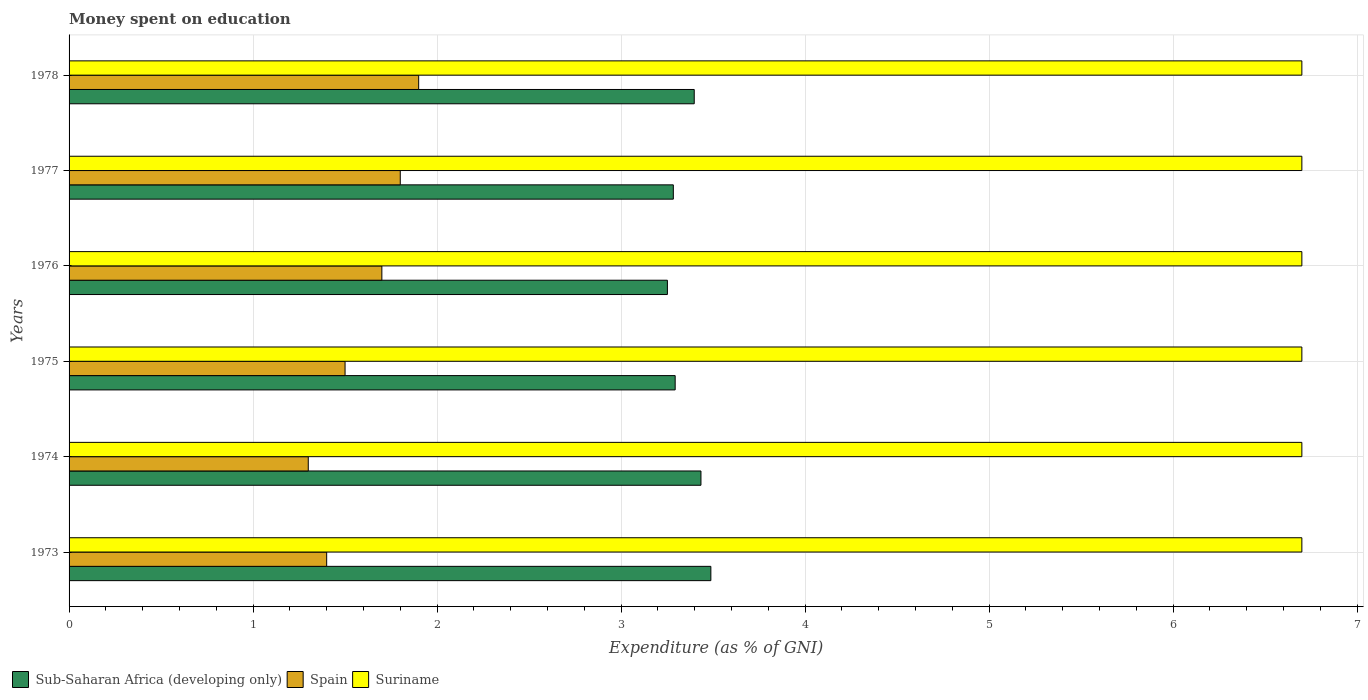How many groups of bars are there?
Give a very brief answer. 6. Are the number of bars on each tick of the Y-axis equal?
Keep it short and to the point. Yes. How many bars are there on the 1st tick from the top?
Make the answer very short. 3. How many bars are there on the 2nd tick from the bottom?
Offer a very short reply. 3. What is the label of the 4th group of bars from the top?
Provide a succinct answer. 1975. What is the amount of money spent on education in Spain in 1978?
Offer a terse response. 1.9. Across all years, what is the maximum amount of money spent on education in Sub-Saharan Africa (developing only)?
Your response must be concise. 3.49. Across all years, what is the minimum amount of money spent on education in Sub-Saharan Africa (developing only)?
Offer a terse response. 3.25. In which year was the amount of money spent on education in Sub-Saharan Africa (developing only) maximum?
Give a very brief answer. 1973. In which year was the amount of money spent on education in Sub-Saharan Africa (developing only) minimum?
Your answer should be very brief. 1976. What is the total amount of money spent on education in Spain in the graph?
Your answer should be compact. 9.6. What is the difference between the amount of money spent on education in Sub-Saharan Africa (developing only) in 1974 and that in 1977?
Keep it short and to the point. 0.15. What is the difference between the amount of money spent on education in Suriname in 1977 and the amount of money spent on education in Sub-Saharan Africa (developing only) in 1976?
Your answer should be compact. 3.45. What is the average amount of money spent on education in Sub-Saharan Africa (developing only) per year?
Your answer should be very brief. 3.36. In the year 1977, what is the difference between the amount of money spent on education in Sub-Saharan Africa (developing only) and amount of money spent on education in Suriname?
Offer a very short reply. -3.42. What is the ratio of the amount of money spent on education in Suriname in 1976 to that in 1978?
Provide a succinct answer. 1. What is the difference between the highest and the second highest amount of money spent on education in Sub-Saharan Africa (developing only)?
Your answer should be very brief. 0.05. What is the difference between the highest and the lowest amount of money spent on education in Sub-Saharan Africa (developing only)?
Provide a short and direct response. 0.24. Is the sum of the amount of money spent on education in Spain in 1974 and 1977 greater than the maximum amount of money spent on education in Sub-Saharan Africa (developing only) across all years?
Make the answer very short. No. What does the 3rd bar from the top in 1973 represents?
Provide a succinct answer. Sub-Saharan Africa (developing only). What does the 2nd bar from the bottom in 1975 represents?
Your response must be concise. Spain. Is it the case that in every year, the sum of the amount of money spent on education in Sub-Saharan Africa (developing only) and amount of money spent on education in Spain is greater than the amount of money spent on education in Suriname?
Make the answer very short. No. Are all the bars in the graph horizontal?
Offer a terse response. Yes. How many years are there in the graph?
Provide a succinct answer. 6. What is the difference between two consecutive major ticks on the X-axis?
Provide a short and direct response. 1. Where does the legend appear in the graph?
Your answer should be compact. Bottom left. How many legend labels are there?
Your response must be concise. 3. What is the title of the graph?
Provide a short and direct response. Money spent on education. What is the label or title of the X-axis?
Your response must be concise. Expenditure (as % of GNI). What is the label or title of the Y-axis?
Your response must be concise. Years. What is the Expenditure (as % of GNI) of Sub-Saharan Africa (developing only) in 1973?
Give a very brief answer. 3.49. What is the Expenditure (as % of GNI) of Suriname in 1973?
Provide a short and direct response. 6.7. What is the Expenditure (as % of GNI) of Sub-Saharan Africa (developing only) in 1974?
Ensure brevity in your answer.  3.43. What is the Expenditure (as % of GNI) in Spain in 1974?
Your answer should be very brief. 1.3. What is the Expenditure (as % of GNI) of Sub-Saharan Africa (developing only) in 1975?
Provide a short and direct response. 3.29. What is the Expenditure (as % of GNI) in Spain in 1975?
Provide a short and direct response. 1.5. What is the Expenditure (as % of GNI) in Suriname in 1975?
Offer a very short reply. 6.7. What is the Expenditure (as % of GNI) of Sub-Saharan Africa (developing only) in 1976?
Your answer should be very brief. 3.25. What is the Expenditure (as % of GNI) of Spain in 1976?
Keep it short and to the point. 1.7. What is the Expenditure (as % of GNI) of Sub-Saharan Africa (developing only) in 1977?
Ensure brevity in your answer.  3.28. What is the Expenditure (as % of GNI) in Suriname in 1977?
Make the answer very short. 6.7. What is the Expenditure (as % of GNI) of Sub-Saharan Africa (developing only) in 1978?
Give a very brief answer. 3.4. Across all years, what is the maximum Expenditure (as % of GNI) in Sub-Saharan Africa (developing only)?
Your answer should be compact. 3.49. Across all years, what is the maximum Expenditure (as % of GNI) in Suriname?
Make the answer very short. 6.7. Across all years, what is the minimum Expenditure (as % of GNI) in Sub-Saharan Africa (developing only)?
Your answer should be very brief. 3.25. Across all years, what is the minimum Expenditure (as % of GNI) of Spain?
Offer a terse response. 1.3. Across all years, what is the minimum Expenditure (as % of GNI) in Suriname?
Your answer should be compact. 6.7. What is the total Expenditure (as % of GNI) in Sub-Saharan Africa (developing only) in the graph?
Make the answer very short. 20.15. What is the total Expenditure (as % of GNI) of Spain in the graph?
Provide a short and direct response. 9.6. What is the total Expenditure (as % of GNI) of Suriname in the graph?
Your answer should be very brief. 40.2. What is the difference between the Expenditure (as % of GNI) in Sub-Saharan Africa (developing only) in 1973 and that in 1974?
Your answer should be compact. 0.05. What is the difference between the Expenditure (as % of GNI) in Spain in 1973 and that in 1974?
Give a very brief answer. 0.1. What is the difference between the Expenditure (as % of GNI) of Suriname in 1973 and that in 1974?
Keep it short and to the point. 0. What is the difference between the Expenditure (as % of GNI) in Sub-Saharan Africa (developing only) in 1973 and that in 1975?
Your answer should be very brief. 0.19. What is the difference between the Expenditure (as % of GNI) in Spain in 1973 and that in 1975?
Ensure brevity in your answer.  -0.1. What is the difference between the Expenditure (as % of GNI) in Suriname in 1973 and that in 1975?
Give a very brief answer. 0. What is the difference between the Expenditure (as % of GNI) of Sub-Saharan Africa (developing only) in 1973 and that in 1976?
Your response must be concise. 0.24. What is the difference between the Expenditure (as % of GNI) of Spain in 1973 and that in 1976?
Provide a short and direct response. -0.3. What is the difference between the Expenditure (as % of GNI) in Sub-Saharan Africa (developing only) in 1973 and that in 1977?
Your answer should be compact. 0.2. What is the difference between the Expenditure (as % of GNI) in Sub-Saharan Africa (developing only) in 1973 and that in 1978?
Make the answer very short. 0.09. What is the difference between the Expenditure (as % of GNI) of Sub-Saharan Africa (developing only) in 1974 and that in 1975?
Your answer should be compact. 0.14. What is the difference between the Expenditure (as % of GNI) in Spain in 1974 and that in 1975?
Your response must be concise. -0.2. What is the difference between the Expenditure (as % of GNI) in Sub-Saharan Africa (developing only) in 1974 and that in 1976?
Provide a short and direct response. 0.18. What is the difference between the Expenditure (as % of GNI) in Spain in 1974 and that in 1976?
Offer a terse response. -0.4. What is the difference between the Expenditure (as % of GNI) of Suriname in 1974 and that in 1976?
Your response must be concise. 0. What is the difference between the Expenditure (as % of GNI) in Sub-Saharan Africa (developing only) in 1974 and that in 1977?
Provide a succinct answer. 0.15. What is the difference between the Expenditure (as % of GNI) of Spain in 1974 and that in 1977?
Offer a terse response. -0.5. What is the difference between the Expenditure (as % of GNI) in Suriname in 1974 and that in 1977?
Your response must be concise. 0. What is the difference between the Expenditure (as % of GNI) of Sub-Saharan Africa (developing only) in 1974 and that in 1978?
Your answer should be very brief. 0.04. What is the difference between the Expenditure (as % of GNI) in Suriname in 1974 and that in 1978?
Your answer should be very brief. 0. What is the difference between the Expenditure (as % of GNI) in Sub-Saharan Africa (developing only) in 1975 and that in 1976?
Ensure brevity in your answer.  0.04. What is the difference between the Expenditure (as % of GNI) of Spain in 1975 and that in 1976?
Ensure brevity in your answer.  -0.2. What is the difference between the Expenditure (as % of GNI) of Suriname in 1975 and that in 1976?
Provide a succinct answer. 0. What is the difference between the Expenditure (as % of GNI) of Spain in 1975 and that in 1977?
Keep it short and to the point. -0.3. What is the difference between the Expenditure (as % of GNI) of Suriname in 1975 and that in 1977?
Offer a terse response. 0. What is the difference between the Expenditure (as % of GNI) of Sub-Saharan Africa (developing only) in 1975 and that in 1978?
Ensure brevity in your answer.  -0.1. What is the difference between the Expenditure (as % of GNI) in Spain in 1975 and that in 1978?
Keep it short and to the point. -0.4. What is the difference between the Expenditure (as % of GNI) in Sub-Saharan Africa (developing only) in 1976 and that in 1977?
Ensure brevity in your answer.  -0.03. What is the difference between the Expenditure (as % of GNI) in Suriname in 1976 and that in 1977?
Your response must be concise. 0. What is the difference between the Expenditure (as % of GNI) in Sub-Saharan Africa (developing only) in 1976 and that in 1978?
Make the answer very short. -0.15. What is the difference between the Expenditure (as % of GNI) of Spain in 1976 and that in 1978?
Provide a short and direct response. -0.2. What is the difference between the Expenditure (as % of GNI) in Sub-Saharan Africa (developing only) in 1977 and that in 1978?
Your answer should be very brief. -0.11. What is the difference between the Expenditure (as % of GNI) of Spain in 1977 and that in 1978?
Keep it short and to the point. -0.1. What is the difference between the Expenditure (as % of GNI) in Suriname in 1977 and that in 1978?
Make the answer very short. 0. What is the difference between the Expenditure (as % of GNI) of Sub-Saharan Africa (developing only) in 1973 and the Expenditure (as % of GNI) of Spain in 1974?
Your answer should be very brief. 2.19. What is the difference between the Expenditure (as % of GNI) in Sub-Saharan Africa (developing only) in 1973 and the Expenditure (as % of GNI) in Suriname in 1974?
Offer a very short reply. -3.21. What is the difference between the Expenditure (as % of GNI) in Sub-Saharan Africa (developing only) in 1973 and the Expenditure (as % of GNI) in Spain in 1975?
Your answer should be very brief. 1.99. What is the difference between the Expenditure (as % of GNI) in Sub-Saharan Africa (developing only) in 1973 and the Expenditure (as % of GNI) in Suriname in 1975?
Make the answer very short. -3.21. What is the difference between the Expenditure (as % of GNI) in Sub-Saharan Africa (developing only) in 1973 and the Expenditure (as % of GNI) in Spain in 1976?
Provide a short and direct response. 1.79. What is the difference between the Expenditure (as % of GNI) in Sub-Saharan Africa (developing only) in 1973 and the Expenditure (as % of GNI) in Suriname in 1976?
Make the answer very short. -3.21. What is the difference between the Expenditure (as % of GNI) in Spain in 1973 and the Expenditure (as % of GNI) in Suriname in 1976?
Your answer should be compact. -5.3. What is the difference between the Expenditure (as % of GNI) in Sub-Saharan Africa (developing only) in 1973 and the Expenditure (as % of GNI) in Spain in 1977?
Provide a succinct answer. 1.69. What is the difference between the Expenditure (as % of GNI) in Sub-Saharan Africa (developing only) in 1973 and the Expenditure (as % of GNI) in Suriname in 1977?
Offer a very short reply. -3.21. What is the difference between the Expenditure (as % of GNI) of Spain in 1973 and the Expenditure (as % of GNI) of Suriname in 1977?
Offer a very short reply. -5.3. What is the difference between the Expenditure (as % of GNI) in Sub-Saharan Africa (developing only) in 1973 and the Expenditure (as % of GNI) in Spain in 1978?
Give a very brief answer. 1.59. What is the difference between the Expenditure (as % of GNI) in Sub-Saharan Africa (developing only) in 1973 and the Expenditure (as % of GNI) in Suriname in 1978?
Give a very brief answer. -3.21. What is the difference between the Expenditure (as % of GNI) of Sub-Saharan Africa (developing only) in 1974 and the Expenditure (as % of GNI) of Spain in 1975?
Offer a very short reply. 1.93. What is the difference between the Expenditure (as % of GNI) in Sub-Saharan Africa (developing only) in 1974 and the Expenditure (as % of GNI) in Suriname in 1975?
Provide a succinct answer. -3.27. What is the difference between the Expenditure (as % of GNI) of Spain in 1974 and the Expenditure (as % of GNI) of Suriname in 1975?
Give a very brief answer. -5.4. What is the difference between the Expenditure (as % of GNI) in Sub-Saharan Africa (developing only) in 1974 and the Expenditure (as % of GNI) in Spain in 1976?
Keep it short and to the point. 1.73. What is the difference between the Expenditure (as % of GNI) of Sub-Saharan Africa (developing only) in 1974 and the Expenditure (as % of GNI) of Suriname in 1976?
Provide a short and direct response. -3.27. What is the difference between the Expenditure (as % of GNI) of Sub-Saharan Africa (developing only) in 1974 and the Expenditure (as % of GNI) of Spain in 1977?
Offer a very short reply. 1.63. What is the difference between the Expenditure (as % of GNI) of Sub-Saharan Africa (developing only) in 1974 and the Expenditure (as % of GNI) of Suriname in 1977?
Make the answer very short. -3.27. What is the difference between the Expenditure (as % of GNI) of Sub-Saharan Africa (developing only) in 1974 and the Expenditure (as % of GNI) of Spain in 1978?
Provide a succinct answer. 1.53. What is the difference between the Expenditure (as % of GNI) in Sub-Saharan Africa (developing only) in 1974 and the Expenditure (as % of GNI) in Suriname in 1978?
Your response must be concise. -3.27. What is the difference between the Expenditure (as % of GNI) in Spain in 1974 and the Expenditure (as % of GNI) in Suriname in 1978?
Your response must be concise. -5.4. What is the difference between the Expenditure (as % of GNI) of Sub-Saharan Africa (developing only) in 1975 and the Expenditure (as % of GNI) of Spain in 1976?
Your response must be concise. 1.59. What is the difference between the Expenditure (as % of GNI) of Sub-Saharan Africa (developing only) in 1975 and the Expenditure (as % of GNI) of Suriname in 1976?
Your answer should be very brief. -3.41. What is the difference between the Expenditure (as % of GNI) of Spain in 1975 and the Expenditure (as % of GNI) of Suriname in 1976?
Make the answer very short. -5.2. What is the difference between the Expenditure (as % of GNI) of Sub-Saharan Africa (developing only) in 1975 and the Expenditure (as % of GNI) of Spain in 1977?
Your response must be concise. 1.49. What is the difference between the Expenditure (as % of GNI) in Sub-Saharan Africa (developing only) in 1975 and the Expenditure (as % of GNI) in Suriname in 1977?
Offer a very short reply. -3.41. What is the difference between the Expenditure (as % of GNI) of Spain in 1975 and the Expenditure (as % of GNI) of Suriname in 1977?
Provide a succinct answer. -5.2. What is the difference between the Expenditure (as % of GNI) of Sub-Saharan Africa (developing only) in 1975 and the Expenditure (as % of GNI) of Spain in 1978?
Keep it short and to the point. 1.39. What is the difference between the Expenditure (as % of GNI) of Sub-Saharan Africa (developing only) in 1975 and the Expenditure (as % of GNI) of Suriname in 1978?
Your answer should be compact. -3.41. What is the difference between the Expenditure (as % of GNI) of Spain in 1975 and the Expenditure (as % of GNI) of Suriname in 1978?
Provide a succinct answer. -5.2. What is the difference between the Expenditure (as % of GNI) in Sub-Saharan Africa (developing only) in 1976 and the Expenditure (as % of GNI) in Spain in 1977?
Offer a terse response. 1.45. What is the difference between the Expenditure (as % of GNI) in Sub-Saharan Africa (developing only) in 1976 and the Expenditure (as % of GNI) in Suriname in 1977?
Your response must be concise. -3.45. What is the difference between the Expenditure (as % of GNI) in Spain in 1976 and the Expenditure (as % of GNI) in Suriname in 1977?
Offer a terse response. -5. What is the difference between the Expenditure (as % of GNI) of Sub-Saharan Africa (developing only) in 1976 and the Expenditure (as % of GNI) of Spain in 1978?
Offer a very short reply. 1.35. What is the difference between the Expenditure (as % of GNI) of Sub-Saharan Africa (developing only) in 1976 and the Expenditure (as % of GNI) of Suriname in 1978?
Provide a short and direct response. -3.45. What is the difference between the Expenditure (as % of GNI) of Sub-Saharan Africa (developing only) in 1977 and the Expenditure (as % of GNI) of Spain in 1978?
Provide a succinct answer. 1.38. What is the difference between the Expenditure (as % of GNI) in Sub-Saharan Africa (developing only) in 1977 and the Expenditure (as % of GNI) in Suriname in 1978?
Make the answer very short. -3.42. What is the average Expenditure (as % of GNI) in Sub-Saharan Africa (developing only) per year?
Offer a very short reply. 3.36. What is the average Expenditure (as % of GNI) in Spain per year?
Offer a terse response. 1.6. What is the average Expenditure (as % of GNI) of Suriname per year?
Make the answer very short. 6.7. In the year 1973, what is the difference between the Expenditure (as % of GNI) in Sub-Saharan Africa (developing only) and Expenditure (as % of GNI) in Spain?
Provide a short and direct response. 2.09. In the year 1973, what is the difference between the Expenditure (as % of GNI) of Sub-Saharan Africa (developing only) and Expenditure (as % of GNI) of Suriname?
Your response must be concise. -3.21. In the year 1973, what is the difference between the Expenditure (as % of GNI) of Spain and Expenditure (as % of GNI) of Suriname?
Ensure brevity in your answer.  -5.3. In the year 1974, what is the difference between the Expenditure (as % of GNI) in Sub-Saharan Africa (developing only) and Expenditure (as % of GNI) in Spain?
Your response must be concise. 2.13. In the year 1974, what is the difference between the Expenditure (as % of GNI) of Sub-Saharan Africa (developing only) and Expenditure (as % of GNI) of Suriname?
Offer a very short reply. -3.27. In the year 1975, what is the difference between the Expenditure (as % of GNI) in Sub-Saharan Africa (developing only) and Expenditure (as % of GNI) in Spain?
Ensure brevity in your answer.  1.79. In the year 1975, what is the difference between the Expenditure (as % of GNI) of Sub-Saharan Africa (developing only) and Expenditure (as % of GNI) of Suriname?
Offer a very short reply. -3.41. In the year 1975, what is the difference between the Expenditure (as % of GNI) of Spain and Expenditure (as % of GNI) of Suriname?
Offer a very short reply. -5.2. In the year 1976, what is the difference between the Expenditure (as % of GNI) in Sub-Saharan Africa (developing only) and Expenditure (as % of GNI) in Spain?
Provide a short and direct response. 1.55. In the year 1976, what is the difference between the Expenditure (as % of GNI) of Sub-Saharan Africa (developing only) and Expenditure (as % of GNI) of Suriname?
Offer a very short reply. -3.45. In the year 1977, what is the difference between the Expenditure (as % of GNI) of Sub-Saharan Africa (developing only) and Expenditure (as % of GNI) of Spain?
Your answer should be compact. 1.48. In the year 1977, what is the difference between the Expenditure (as % of GNI) of Sub-Saharan Africa (developing only) and Expenditure (as % of GNI) of Suriname?
Your answer should be very brief. -3.42. In the year 1978, what is the difference between the Expenditure (as % of GNI) of Sub-Saharan Africa (developing only) and Expenditure (as % of GNI) of Spain?
Offer a terse response. 1.5. In the year 1978, what is the difference between the Expenditure (as % of GNI) of Sub-Saharan Africa (developing only) and Expenditure (as % of GNI) of Suriname?
Your response must be concise. -3.3. In the year 1978, what is the difference between the Expenditure (as % of GNI) in Spain and Expenditure (as % of GNI) in Suriname?
Provide a short and direct response. -4.8. What is the ratio of the Expenditure (as % of GNI) of Sub-Saharan Africa (developing only) in 1973 to that in 1974?
Give a very brief answer. 1.02. What is the ratio of the Expenditure (as % of GNI) in Sub-Saharan Africa (developing only) in 1973 to that in 1975?
Give a very brief answer. 1.06. What is the ratio of the Expenditure (as % of GNI) in Spain in 1973 to that in 1975?
Your response must be concise. 0.93. What is the ratio of the Expenditure (as % of GNI) in Suriname in 1973 to that in 1975?
Your answer should be very brief. 1. What is the ratio of the Expenditure (as % of GNI) in Sub-Saharan Africa (developing only) in 1973 to that in 1976?
Provide a succinct answer. 1.07. What is the ratio of the Expenditure (as % of GNI) of Spain in 1973 to that in 1976?
Ensure brevity in your answer.  0.82. What is the ratio of the Expenditure (as % of GNI) in Suriname in 1973 to that in 1976?
Give a very brief answer. 1. What is the ratio of the Expenditure (as % of GNI) of Sub-Saharan Africa (developing only) in 1973 to that in 1977?
Keep it short and to the point. 1.06. What is the ratio of the Expenditure (as % of GNI) of Spain in 1973 to that in 1977?
Keep it short and to the point. 0.78. What is the ratio of the Expenditure (as % of GNI) of Sub-Saharan Africa (developing only) in 1973 to that in 1978?
Offer a terse response. 1.03. What is the ratio of the Expenditure (as % of GNI) of Spain in 1973 to that in 1978?
Offer a terse response. 0.74. What is the ratio of the Expenditure (as % of GNI) in Sub-Saharan Africa (developing only) in 1974 to that in 1975?
Offer a very short reply. 1.04. What is the ratio of the Expenditure (as % of GNI) of Spain in 1974 to that in 1975?
Offer a terse response. 0.87. What is the ratio of the Expenditure (as % of GNI) of Suriname in 1974 to that in 1975?
Provide a succinct answer. 1. What is the ratio of the Expenditure (as % of GNI) in Sub-Saharan Africa (developing only) in 1974 to that in 1976?
Your answer should be compact. 1.06. What is the ratio of the Expenditure (as % of GNI) in Spain in 1974 to that in 1976?
Offer a terse response. 0.76. What is the ratio of the Expenditure (as % of GNI) in Sub-Saharan Africa (developing only) in 1974 to that in 1977?
Your answer should be compact. 1.05. What is the ratio of the Expenditure (as % of GNI) in Spain in 1974 to that in 1977?
Provide a succinct answer. 0.72. What is the ratio of the Expenditure (as % of GNI) in Sub-Saharan Africa (developing only) in 1974 to that in 1978?
Offer a terse response. 1.01. What is the ratio of the Expenditure (as % of GNI) of Spain in 1974 to that in 1978?
Provide a succinct answer. 0.68. What is the ratio of the Expenditure (as % of GNI) in Sub-Saharan Africa (developing only) in 1975 to that in 1976?
Offer a terse response. 1.01. What is the ratio of the Expenditure (as % of GNI) of Spain in 1975 to that in 1976?
Your answer should be compact. 0.88. What is the ratio of the Expenditure (as % of GNI) of Sub-Saharan Africa (developing only) in 1975 to that in 1977?
Keep it short and to the point. 1. What is the ratio of the Expenditure (as % of GNI) in Suriname in 1975 to that in 1977?
Offer a very short reply. 1. What is the ratio of the Expenditure (as % of GNI) of Sub-Saharan Africa (developing only) in 1975 to that in 1978?
Your response must be concise. 0.97. What is the ratio of the Expenditure (as % of GNI) in Spain in 1975 to that in 1978?
Provide a short and direct response. 0.79. What is the ratio of the Expenditure (as % of GNI) in Suriname in 1975 to that in 1978?
Offer a very short reply. 1. What is the ratio of the Expenditure (as % of GNI) in Sub-Saharan Africa (developing only) in 1976 to that in 1977?
Offer a terse response. 0.99. What is the ratio of the Expenditure (as % of GNI) of Spain in 1976 to that in 1977?
Your response must be concise. 0.94. What is the ratio of the Expenditure (as % of GNI) in Suriname in 1976 to that in 1977?
Offer a very short reply. 1. What is the ratio of the Expenditure (as % of GNI) of Sub-Saharan Africa (developing only) in 1976 to that in 1978?
Ensure brevity in your answer.  0.96. What is the ratio of the Expenditure (as % of GNI) of Spain in 1976 to that in 1978?
Provide a short and direct response. 0.89. What is the ratio of the Expenditure (as % of GNI) in Suriname in 1976 to that in 1978?
Provide a succinct answer. 1. What is the ratio of the Expenditure (as % of GNI) in Sub-Saharan Africa (developing only) in 1977 to that in 1978?
Your answer should be very brief. 0.97. What is the ratio of the Expenditure (as % of GNI) in Suriname in 1977 to that in 1978?
Your answer should be compact. 1. What is the difference between the highest and the second highest Expenditure (as % of GNI) of Sub-Saharan Africa (developing only)?
Give a very brief answer. 0.05. What is the difference between the highest and the second highest Expenditure (as % of GNI) of Suriname?
Keep it short and to the point. 0. What is the difference between the highest and the lowest Expenditure (as % of GNI) in Sub-Saharan Africa (developing only)?
Provide a short and direct response. 0.24. 